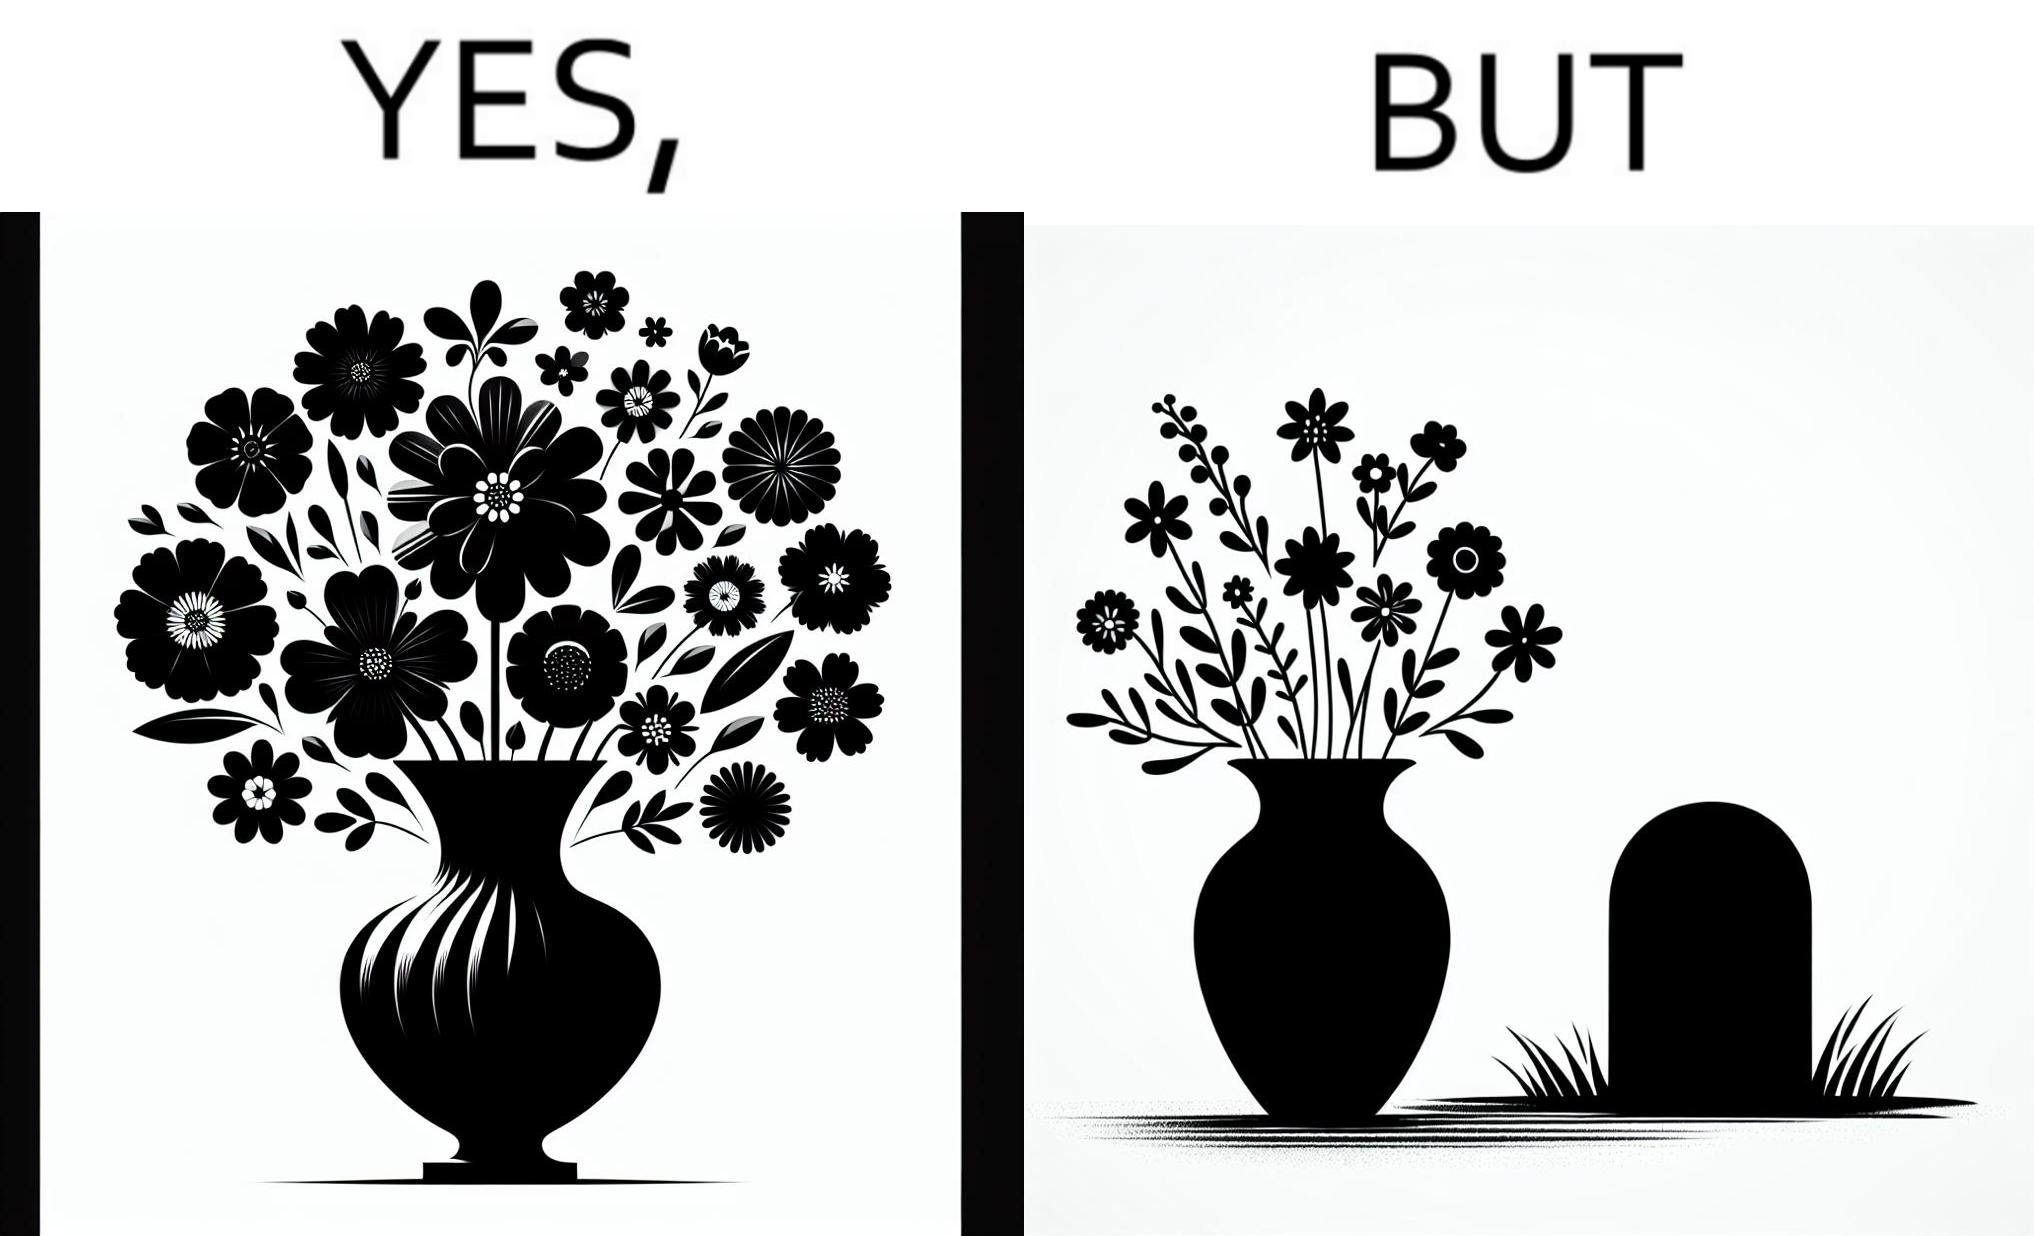Describe what you see in the left and right parts of this image. In the left part of the image: a beautiful vase of full of different beautiful flowers In the right part of the image: a beautiful vase of full of different beautiful flowers put in front of someone's grave stone 